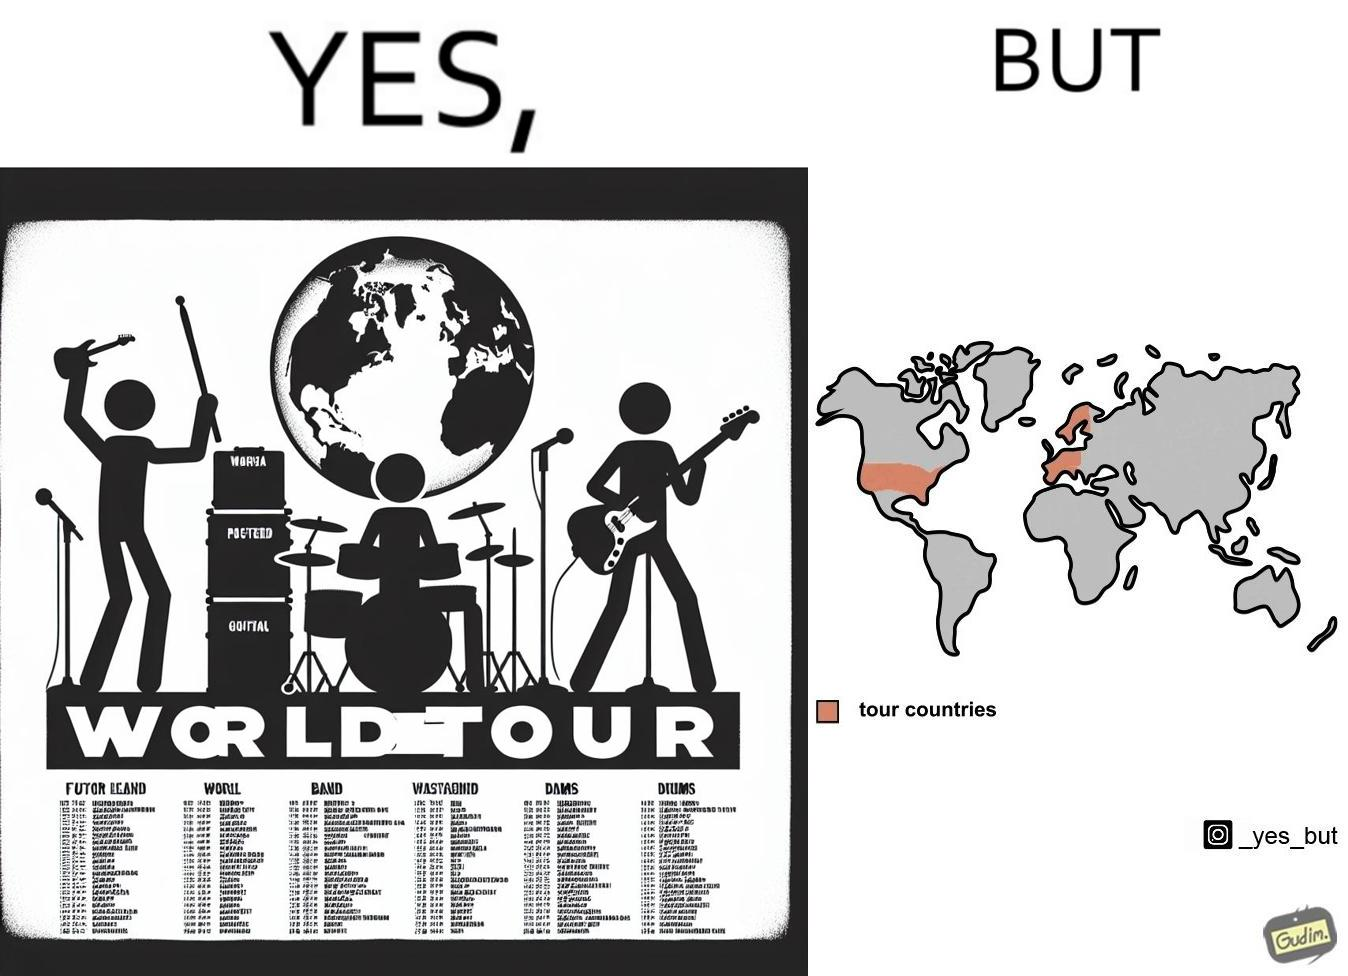Does this image contain satire or humor? Yes, this image is satirical. 